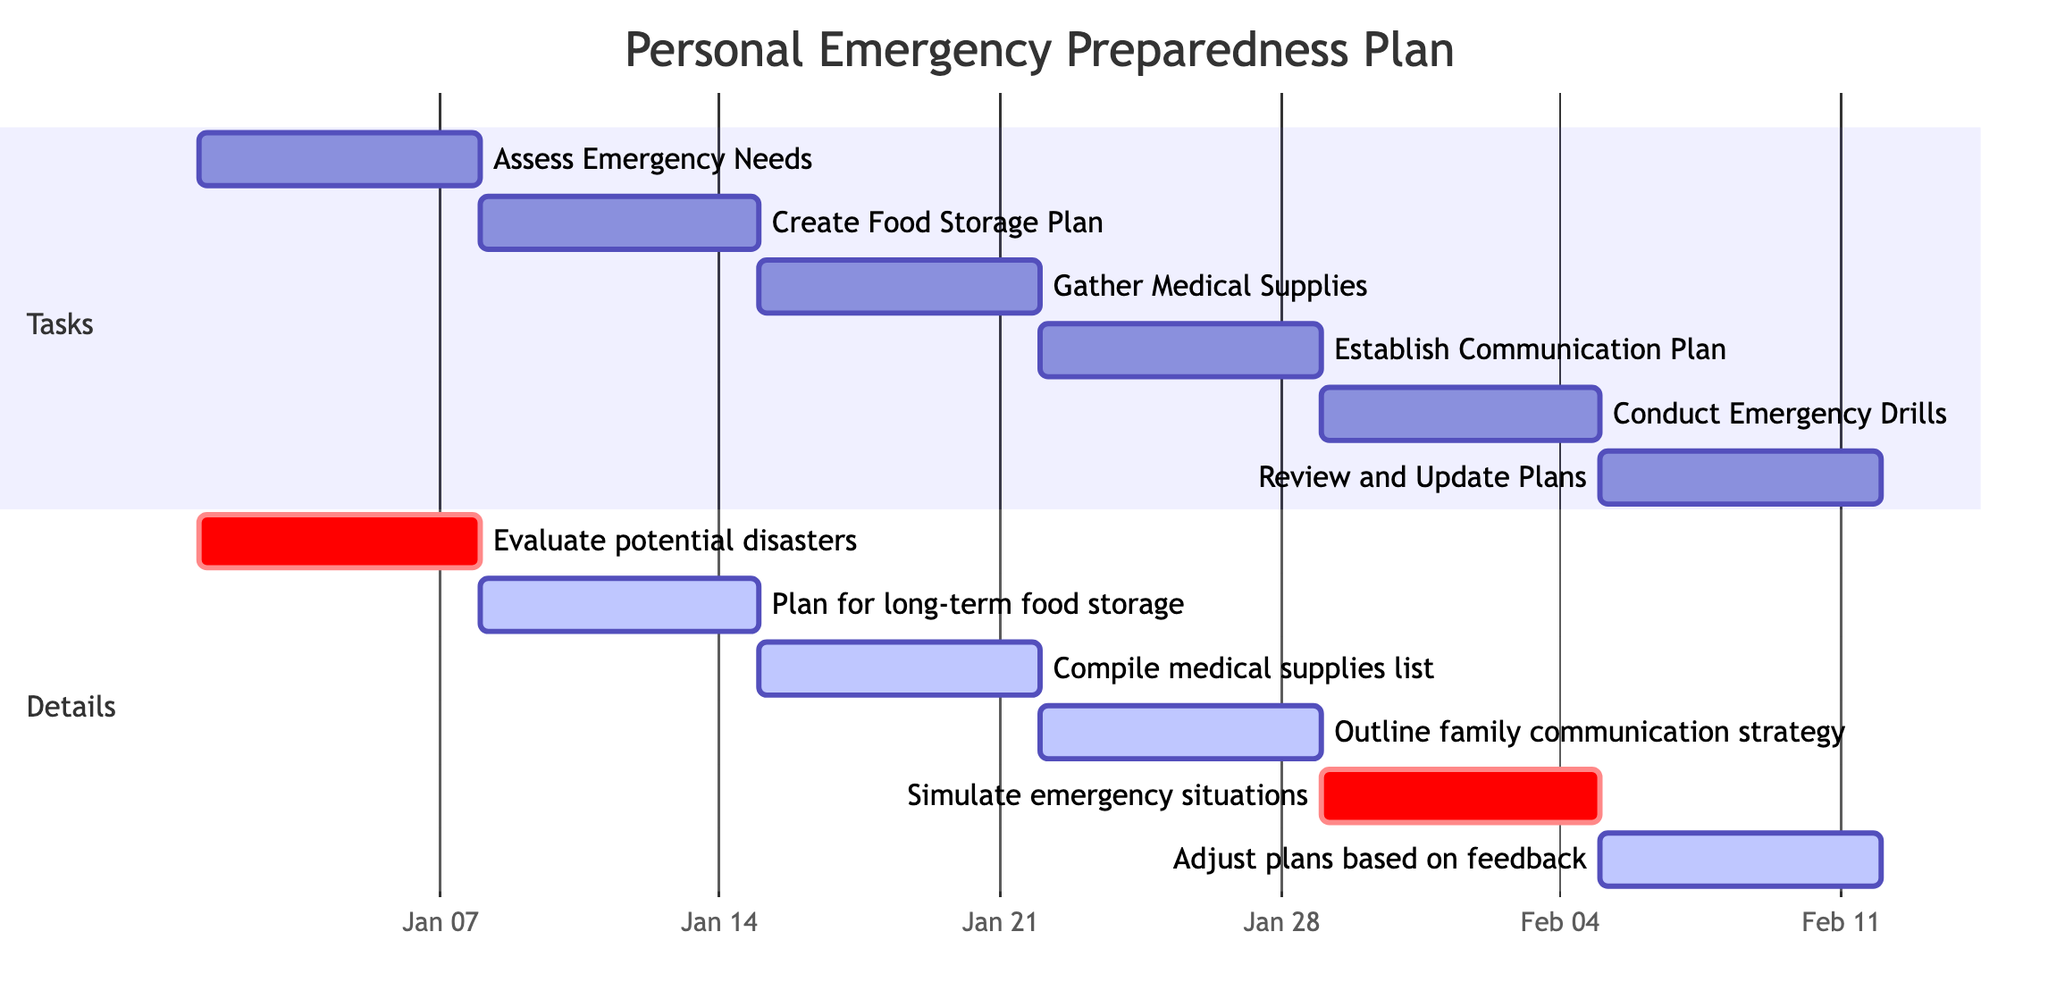What is the duration of the "Assess Emergency Needs" task? The task "Assess Emergency Needs" is defined in the diagram as having a duration of "1 week". This information is directly provided in the task's details within the chart.
Answer: 1 week When does the "Gather Medical Supplies" task begin? The "Gather Medical Supplies" task starts after the "Create Food Storage Plan" task, which has a start date of January 8, 2024. Since the "Create Food Storage Plan" lasts for 1 week, "Gather Medical Supplies" begins on January 15, 2024.
Answer: January 15, 2024 How many total tasks are outlined in the Gantt chart? The Gantt chart has a total of six tasks listed in the "Tasks" section. By counting each task individually, we confirm that there are exactly six unique tasks defined.
Answer: 6 Which task is classified as critical in the diagram? The tasks "Evaluate potential disasters" and "Simulate emergency situations" are marked as critical in the diagram. They are listed under the "Details" section with the keyword "crit".
Answer: Evaluate potential disasters and Simulate emergency situations What is the end date for the "Review and Update Plans" task? The "Review and Update Plans" task occurs after the previous task "Conduct Emergency Drills," which ends on February 4, 2024. Therefore, "Review and Update Plans" starts on February 5, 2024, and since it lasts for 1 week, it will end on February 11, 2024.
Answer: February 11, 2024 Which task directly follows "Establish Communication Plan"? "Conduct Emergency Drills" is the task that comes directly after "Establish Communication Plan" in the sequence of tasks represented in the Gantt chart, signifying its order.
Answer: Conduct Emergency Drills What is the relationship between "Gather Medical Supplies" and "Establish Communication Plan"? "Gather Medical Supplies" follows directly after "Create Food Storage Plan" and precedes "Establish Communication Plan." Therefore, there is a sequential relationship where "Gather Medical Supplies" must be completed before executing "Establish Communication Plan."
Answer: Sequential relationship What is the main focus of the "Create Food Storage Plan" task? The main focus of the "Create Food Storage Plan" task is to develop a strategy for long-term food storage. The specific details include choosing non-perishable food items that meet dietary preferences and needs, which captures the essence of the task.
Answer: Develop a plan for long-term food storage 